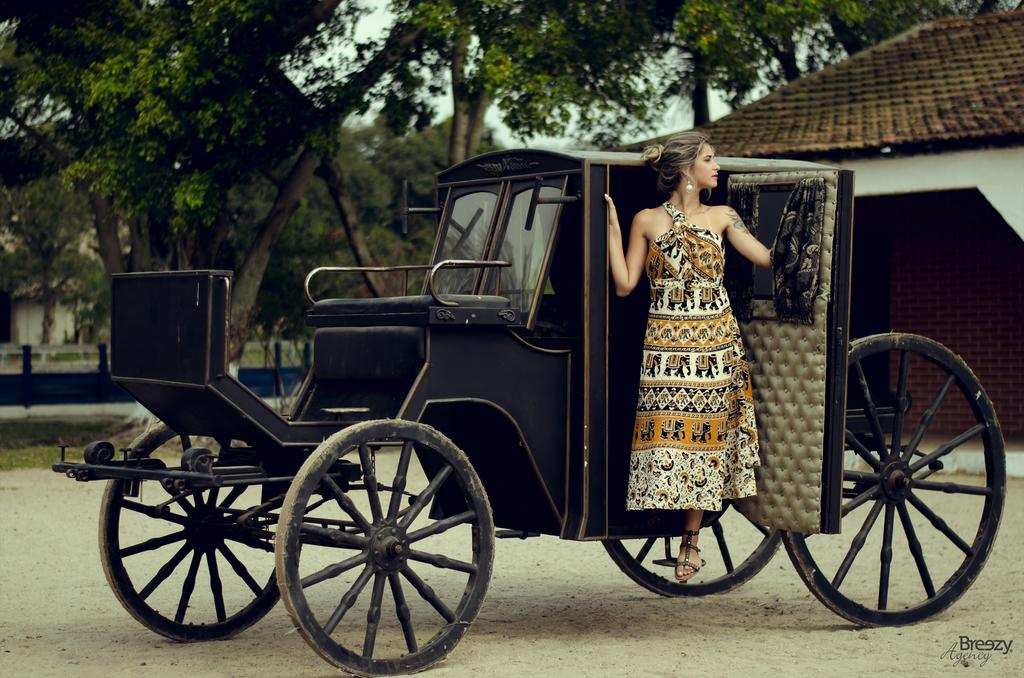What is the main subject in the image? There is a vehicle in the image. Can you describe the woman in the image? There is a woman in the image. What can be seen in the background of the image? There are trees and the sky visible in the background of the image. What type of rhythm can be heard coming from the balloon in the image? There is no balloon present in the image, and therefore no rhythm can be heard. 